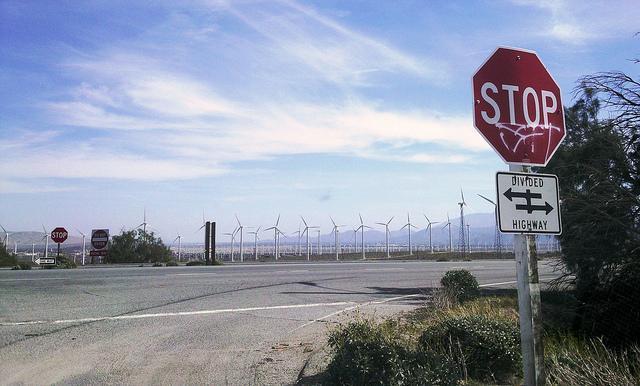How many pieces of broccoli do you see?
Give a very brief answer. 0. 